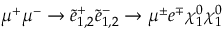Convert formula to latex. <formula><loc_0><loc_0><loc_500><loc_500>\mu ^ { + } \mu ^ { - } \to \tilde { e } _ { 1 , 2 } ^ { + } \tilde { e } _ { 1 , 2 } ^ { - } \to \mu ^ { \pm } e ^ { \mp } \chi _ { 1 } ^ { 0 } \chi _ { 1 } ^ { 0 }</formula> 